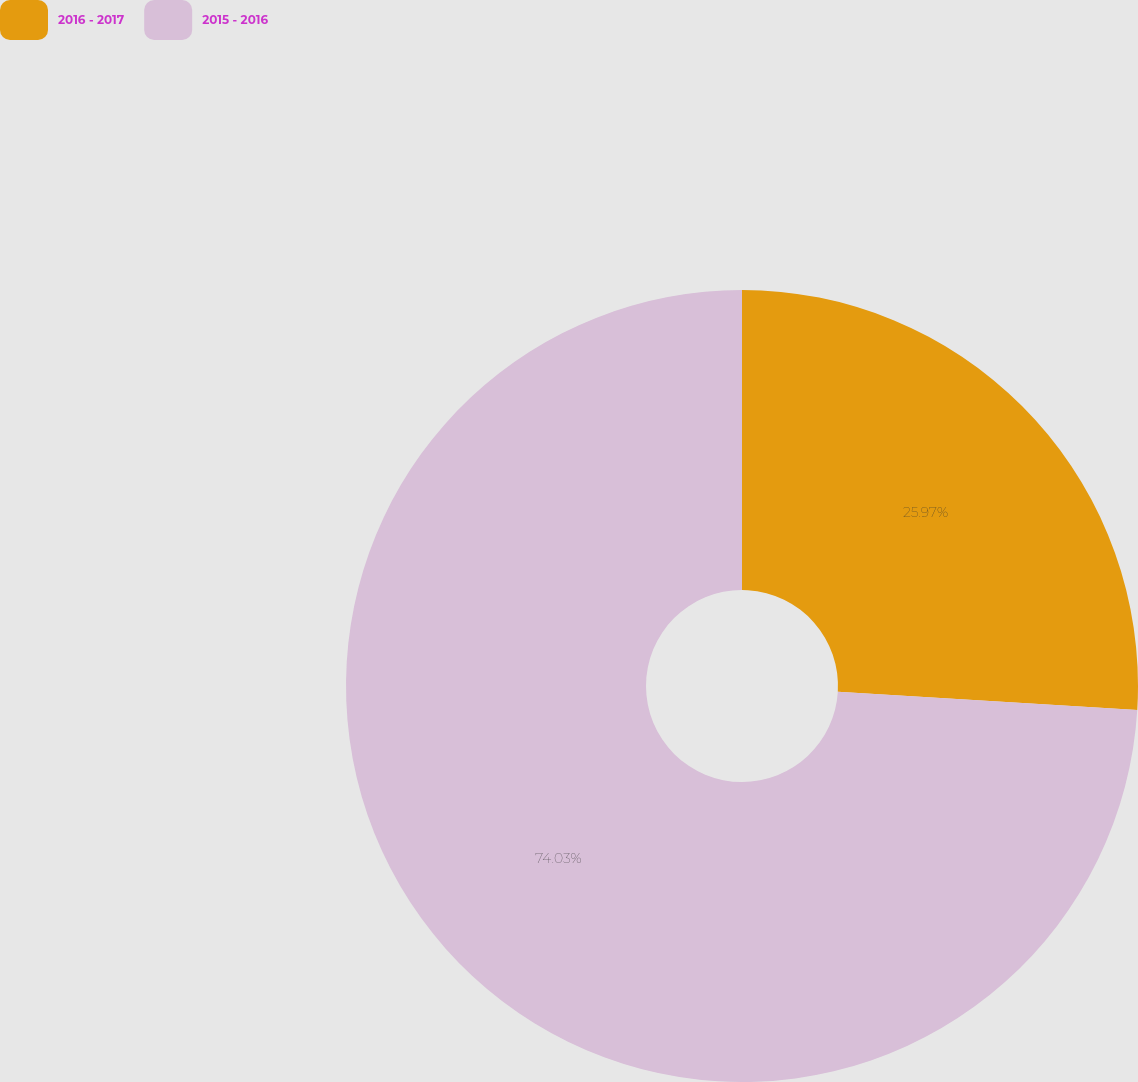<chart> <loc_0><loc_0><loc_500><loc_500><pie_chart><fcel>2016 - 2017<fcel>2015 - 2016<nl><fcel>25.97%<fcel>74.03%<nl></chart> 